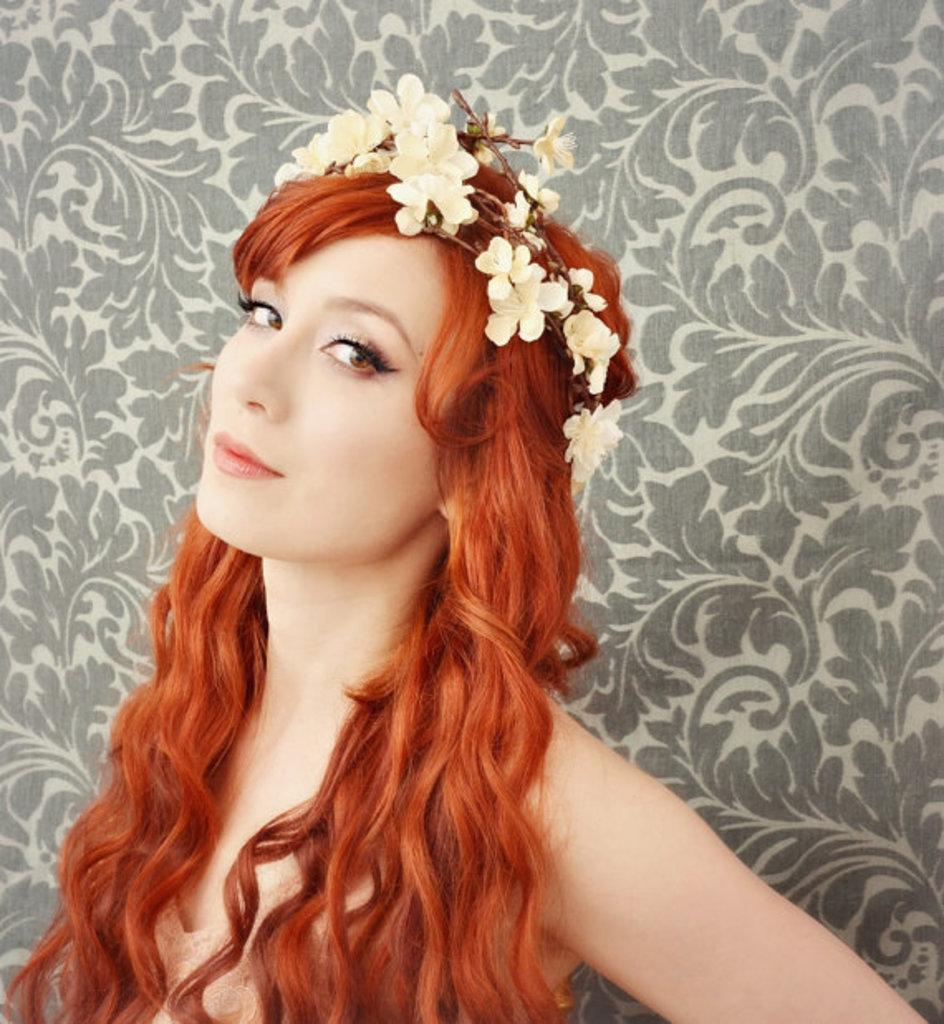What is the main subject of the image? There is a woman standing in the image. What is the woman wearing on her head? The woman is wearing a flowered crown. Can you describe the background of the image? There is a decorated wall in the background of the image. What type of pickle is being served at the club in the image? There is no club or pickle present in the image; it features a woman wearing a flowered crown with a decorated wall in the background. 